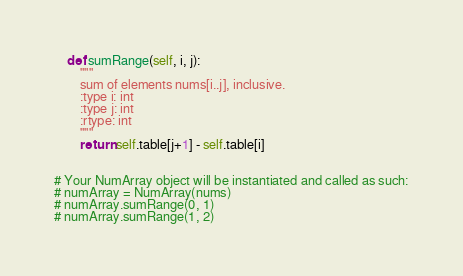<code> <loc_0><loc_0><loc_500><loc_500><_Python_>
    def sumRange(self, i, j):
        """
        sum of elements nums[i..j], inclusive.
        :type i: int
        :type j: int
        :rtype: int
        """
        return self.table[j+1] - self.table[i]


# Your NumArray object will be instantiated and called as such:
# numArray = NumArray(nums)
# numArray.sumRange(0, 1)
# numArray.sumRange(1, 2)
</code> 